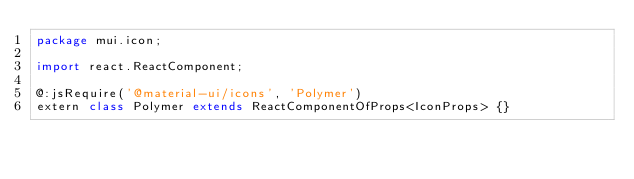Convert code to text. <code><loc_0><loc_0><loc_500><loc_500><_Haxe_>package mui.icon;

import react.ReactComponent;

@:jsRequire('@material-ui/icons', 'Polymer')
extern class Polymer extends ReactComponentOfProps<IconProps> {}
</code> 